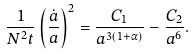<formula> <loc_0><loc_0><loc_500><loc_500>\frac { 1 } { N ^ { 2 } t } \left ( \frac { \dot { a } } { a } \right ) ^ { 2 } = \frac { C _ { 1 } } { a ^ { 3 ( 1 + \alpha ) } } - \frac { C _ { 2 } } { a ^ { 6 } } .</formula> 